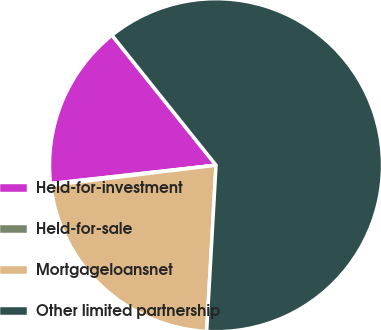Convert chart. <chart><loc_0><loc_0><loc_500><loc_500><pie_chart><fcel>Held-for-investment<fcel>Held-for-sale<fcel>Mortgageloansnet<fcel>Other limited partnership<nl><fcel>16.02%<fcel>0.17%<fcel>22.17%<fcel>61.64%<nl></chart> 